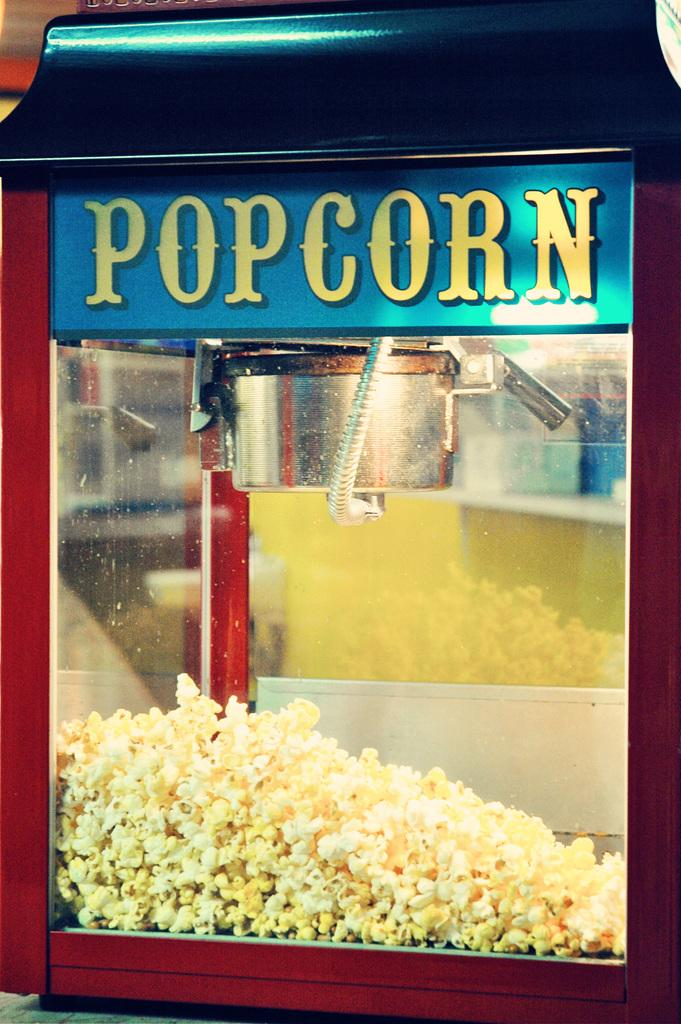<image>
Give a short and clear explanation of the subsequent image. The popcorn maker has a blue and yellow sign. 